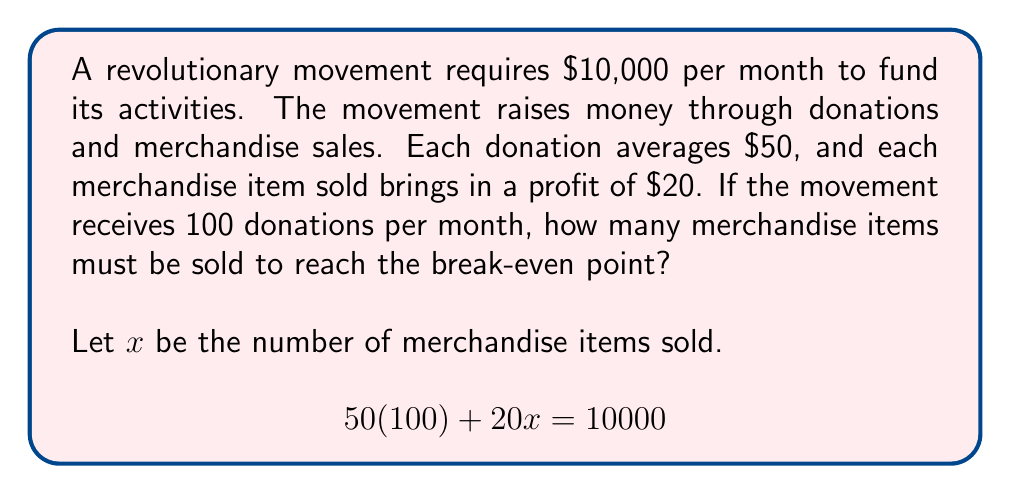Can you solve this math problem? To solve this problem, we'll follow these steps:

1. Identify the given information:
   - Monthly funding requirement: $10,000
   - Average donation: $50
   - Profit per merchandise item: $20
   - Number of donations per month: 100

2. Set up the equation:
   $$ \text{(Donations)} + \text{(Merchandise Sales)} = \text{(Total Funding Required)} $$
   $$ 50(100) + 20x = 10000 $$

3. Simplify the left side of the equation:
   $$ 5000 + 20x = 10000 $$

4. Subtract 5000 from both sides:
   $$ 20x = 5000 $$

5. Divide both sides by 20:
   $$ x = \frac{5000}{20} = 250 $$

Therefore, the movement needs to sell 250 merchandise items to reach the break-even point.
Answer: 250 merchandise items 